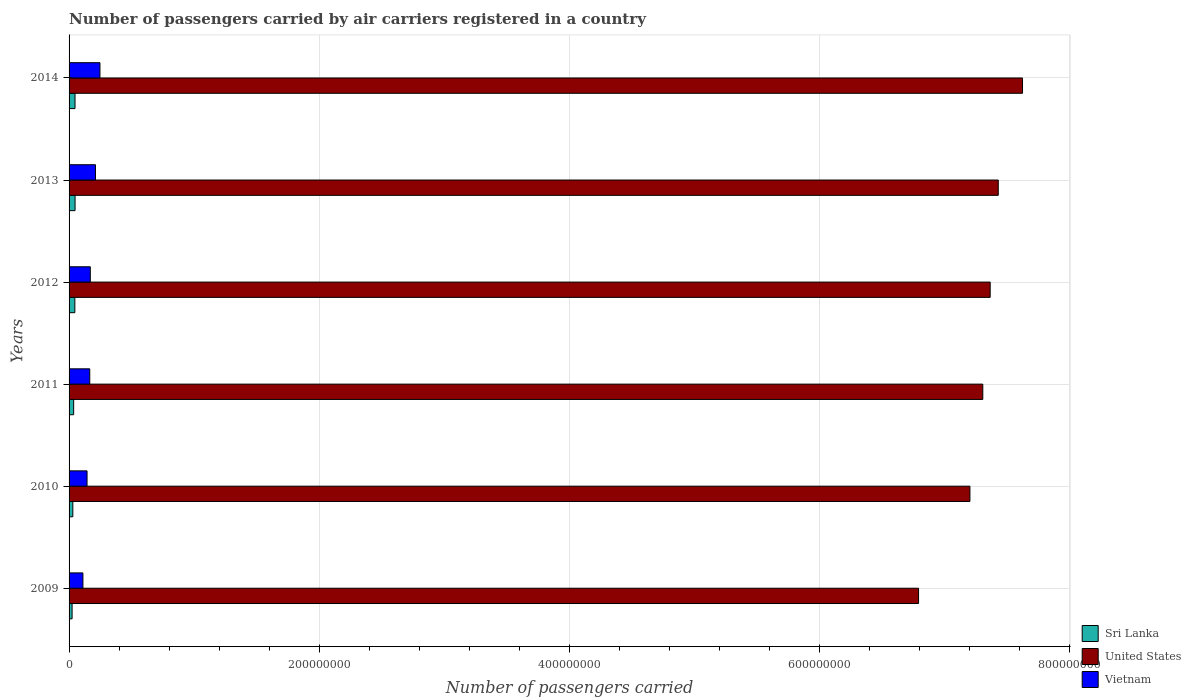Are the number of bars per tick equal to the number of legend labels?
Your answer should be very brief. Yes. How many bars are there on the 3rd tick from the top?
Your response must be concise. 3. What is the number of passengers carried by air carriers in Sri Lanka in 2011?
Provide a short and direct response. 3.67e+06. Across all years, what is the maximum number of passengers carried by air carriers in Vietnam?
Give a very brief answer. 2.47e+07. Across all years, what is the minimum number of passengers carried by air carriers in Vietnam?
Provide a short and direct response. 1.11e+07. In which year was the number of passengers carried by air carriers in Vietnam maximum?
Your response must be concise. 2014. What is the total number of passengers carried by air carriers in Vietnam in the graph?
Your response must be concise. 1.05e+08. What is the difference between the number of passengers carried by air carriers in Vietnam in 2010 and that in 2014?
Offer a terse response. -1.03e+07. What is the difference between the number of passengers carried by air carriers in Vietnam in 2010 and the number of passengers carried by air carriers in United States in 2011?
Make the answer very short. -7.16e+08. What is the average number of passengers carried by air carriers in United States per year?
Provide a succinct answer. 7.29e+08. In the year 2012, what is the difference between the number of passengers carried by air carriers in United States and number of passengers carried by air carriers in Sri Lanka?
Your answer should be compact. 7.32e+08. In how many years, is the number of passengers carried by air carriers in United States greater than 760000000 ?
Give a very brief answer. 1. What is the ratio of the number of passengers carried by air carriers in United States in 2010 to that in 2011?
Your response must be concise. 0.99. What is the difference between the highest and the second highest number of passengers carried by air carriers in United States?
Your answer should be compact. 1.94e+07. What is the difference between the highest and the lowest number of passengers carried by air carriers in United States?
Keep it short and to the point. 8.31e+07. What does the 3rd bar from the top in 2009 represents?
Make the answer very short. Sri Lanka. What does the 3rd bar from the bottom in 2013 represents?
Ensure brevity in your answer.  Vietnam. How many years are there in the graph?
Your answer should be compact. 6. What is the difference between two consecutive major ticks on the X-axis?
Offer a terse response. 2.00e+08. Are the values on the major ticks of X-axis written in scientific E-notation?
Offer a terse response. No. Does the graph contain any zero values?
Provide a succinct answer. No. Does the graph contain grids?
Provide a succinct answer. Yes. How many legend labels are there?
Provide a short and direct response. 3. What is the title of the graph?
Provide a short and direct response. Number of passengers carried by air carriers registered in a country. What is the label or title of the X-axis?
Your response must be concise. Number of passengers carried. What is the label or title of the Y-axis?
Ensure brevity in your answer.  Years. What is the Number of passengers carried of Sri Lanka in 2009?
Your answer should be very brief. 2.42e+06. What is the Number of passengers carried of United States in 2009?
Ensure brevity in your answer.  6.79e+08. What is the Number of passengers carried in Vietnam in 2009?
Give a very brief answer. 1.11e+07. What is the Number of passengers carried of Sri Lanka in 2010?
Your answer should be very brief. 3.01e+06. What is the Number of passengers carried in United States in 2010?
Offer a very short reply. 7.20e+08. What is the Number of passengers carried of Vietnam in 2010?
Ensure brevity in your answer.  1.44e+07. What is the Number of passengers carried of Sri Lanka in 2011?
Provide a short and direct response. 3.67e+06. What is the Number of passengers carried of United States in 2011?
Make the answer very short. 7.31e+08. What is the Number of passengers carried of Vietnam in 2011?
Ensure brevity in your answer.  1.65e+07. What is the Number of passengers carried in Sri Lanka in 2012?
Make the answer very short. 4.62e+06. What is the Number of passengers carried in United States in 2012?
Provide a short and direct response. 7.37e+08. What is the Number of passengers carried in Vietnam in 2012?
Your answer should be compact. 1.70e+07. What is the Number of passengers carried in Sri Lanka in 2013?
Your answer should be very brief. 4.79e+06. What is the Number of passengers carried of United States in 2013?
Your answer should be very brief. 7.43e+08. What is the Number of passengers carried of Vietnam in 2013?
Your answer should be compact. 2.11e+07. What is the Number of passengers carried of Sri Lanka in 2014?
Offer a very short reply. 4.76e+06. What is the Number of passengers carried of United States in 2014?
Your response must be concise. 7.63e+08. What is the Number of passengers carried of Vietnam in 2014?
Give a very brief answer. 2.47e+07. Across all years, what is the maximum Number of passengers carried in Sri Lanka?
Ensure brevity in your answer.  4.79e+06. Across all years, what is the maximum Number of passengers carried in United States?
Offer a very short reply. 7.63e+08. Across all years, what is the maximum Number of passengers carried of Vietnam?
Give a very brief answer. 2.47e+07. Across all years, what is the minimum Number of passengers carried of Sri Lanka?
Keep it short and to the point. 2.42e+06. Across all years, what is the minimum Number of passengers carried of United States?
Provide a succinct answer. 6.79e+08. Across all years, what is the minimum Number of passengers carried in Vietnam?
Your answer should be very brief. 1.11e+07. What is the total Number of passengers carried in Sri Lanka in the graph?
Keep it short and to the point. 2.33e+07. What is the total Number of passengers carried of United States in the graph?
Keep it short and to the point. 4.37e+09. What is the total Number of passengers carried of Vietnam in the graph?
Offer a terse response. 1.05e+08. What is the difference between the Number of passengers carried in Sri Lanka in 2009 and that in 2010?
Your answer should be compact. -5.91e+05. What is the difference between the Number of passengers carried of United States in 2009 and that in 2010?
Make the answer very short. -4.11e+07. What is the difference between the Number of passengers carried of Vietnam in 2009 and that in 2010?
Provide a short and direct response. -3.30e+06. What is the difference between the Number of passengers carried of Sri Lanka in 2009 and that in 2011?
Your answer should be very brief. -1.25e+06. What is the difference between the Number of passengers carried of United States in 2009 and that in 2011?
Offer a very short reply. -5.14e+07. What is the difference between the Number of passengers carried of Vietnam in 2009 and that in 2011?
Your response must be concise. -5.47e+06. What is the difference between the Number of passengers carried in Sri Lanka in 2009 and that in 2012?
Make the answer very short. -2.20e+06. What is the difference between the Number of passengers carried of United States in 2009 and that in 2012?
Your answer should be compact. -5.73e+07. What is the difference between the Number of passengers carried of Vietnam in 2009 and that in 2012?
Your answer should be very brief. -5.90e+06. What is the difference between the Number of passengers carried of Sri Lanka in 2009 and that in 2013?
Give a very brief answer. -2.38e+06. What is the difference between the Number of passengers carried of United States in 2009 and that in 2013?
Your answer should be compact. -6.37e+07. What is the difference between the Number of passengers carried of Vietnam in 2009 and that in 2013?
Your answer should be very brief. -1.00e+07. What is the difference between the Number of passengers carried of Sri Lanka in 2009 and that in 2014?
Your answer should be very brief. -2.34e+06. What is the difference between the Number of passengers carried in United States in 2009 and that in 2014?
Give a very brief answer. -8.31e+07. What is the difference between the Number of passengers carried of Vietnam in 2009 and that in 2014?
Ensure brevity in your answer.  -1.36e+07. What is the difference between the Number of passengers carried in Sri Lanka in 2010 and that in 2011?
Offer a terse response. -6.57e+05. What is the difference between the Number of passengers carried in United States in 2010 and that in 2011?
Provide a succinct answer. -1.03e+07. What is the difference between the Number of passengers carried of Vietnam in 2010 and that in 2011?
Provide a short and direct response. -2.17e+06. What is the difference between the Number of passengers carried in Sri Lanka in 2010 and that in 2012?
Your response must be concise. -1.61e+06. What is the difference between the Number of passengers carried in United States in 2010 and that in 2012?
Provide a succinct answer. -1.62e+07. What is the difference between the Number of passengers carried of Vietnam in 2010 and that in 2012?
Give a very brief answer. -2.60e+06. What is the difference between the Number of passengers carried in Sri Lanka in 2010 and that in 2013?
Your response must be concise. -1.79e+06. What is the difference between the Number of passengers carried of United States in 2010 and that in 2013?
Provide a short and direct response. -2.27e+07. What is the difference between the Number of passengers carried of Vietnam in 2010 and that in 2013?
Your answer should be compact. -6.74e+06. What is the difference between the Number of passengers carried in Sri Lanka in 2010 and that in 2014?
Ensure brevity in your answer.  -1.75e+06. What is the difference between the Number of passengers carried of United States in 2010 and that in 2014?
Ensure brevity in your answer.  -4.21e+07. What is the difference between the Number of passengers carried of Vietnam in 2010 and that in 2014?
Your answer should be compact. -1.03e+07. What is the difference between the Number of passengers carried of Sri Lanka in 2011 and that in 2012?
Make the answer very short. -9.51e+05. What is the difference between the Number of passengers carried in United States in 2011 and that in 2012?
Your response must be concise. -5.90e+06. What is the difference between the Number of passengers carried in Vietnam in 2011 and that in 2012?
Offer a very short reply. -4.32e+05. What is the difference between the Number of passengers carried of Sri Lanka in 2011 and that in 2013?
Offer a very short reply. -1.13e+06. What is the difference between the Number of passengers carried of United States in 2011 and that in 2013?
Keep it short and to the point. -1.24e+07. What is the difference between the Number of passengers carried in Vietnam in 2011 and that in 2013?
Your answer should be very brief. -4.58e+06. What is the difference between the Number of passengers carried of Sri Lanka in 2011 and that in 2014?
Ensure brevity in your answer.  -1.09e+06. What is the difference between the Number of passengers carried of United States in 2011 and that in 2014?
Offer a terse response. -3.18e+07. What is the difference between the Number of passengers carried of Vietnam in 2011 and that in 2014?
Provide a succinct answer. -8.16e+06. What is the difference between the Number of passengers carried of Sri Lanka in 2012 and that in 2013?
Your response must be concise. -1.77e+05. What is the difference between the Number of passengers carried in United States in 2012 and that in 2013?
Keep it short and to the point. -6.47e+06. What is the difference between the Number of passengers carried in Vietnam in 2012 and that in 2013?
Ensure brevity in your answer.  -4.15e+06. What is the difference between the Number of passengers carried in Sri Lanka in 2012 and that in 2014?
Your response must be concise. -1.40e+05. What is the difference between the Number of passengers carried of United States in 2012 and that in 2014?
Offer a terse response. -2.59e+07. What is the difference between the Number of passengers carried of Vietnam in 2012 and that in 2014?
Make the answer very short. -7.73e+06. What is the difference between the Number of passengers carried in Sri Lanka in 2013 and that in 2014?
Your response must be concise. 3.75e+04. What is the difference between the Number of passengers carried in United States in 2013 and that in 2014?
Offer a very short reply. -1.94e+07. What is the difference between the Number of passengers carried of Vietnam in 2013 and that in 2014?
Give a very brief answer. -3.58e+06. What is the difference between the Number of passengers carried in Sri Lanka in 2009 and the Number of passengers carried in United States in 2010?
Make the answer very short. -7.18e+08. What is the difference between the Number of passengers carried in Sri Lanka in 2009 and the Number of passengers carried in Vietnam in 2010?
Provide a short and direct response. -1.20e+07. What is the difference between the Number of passengers carried in United States in 2009 and the Number of passengers carried in Vietnam in 2010?
Provide a succinct answer. 6.65e+08. What is the difference between the Number of passengers carried in Sri Lanka in 2009 and the Number of passengers carried in United States in 2011?
Offer a very short reply. -7.28e+08. What is the difference between the Number of passengers carried in Sri Lanka in 2009 and the Number of passengers carried in Vietnam in 2011?
Offer a very short reply. -1.41e+07. What is the difference between the Number of passengers carried of United States in 2009 and the Number of passengers carried of Vietnam in 2011?
Your answer should be compact. 6.63e+08. What is the difference between the Number of passengers carried of Sri Lanka in 2009 and the Number of passengers carried of United States in 2012?
Your answer should be very brief. -7.34e+08. What is the difference between the Number of passengers carried in Sri Lanka in 2009 and the Number of passengers carried in Vietnam in 2012?
Offer a very short reply. -1.46e+07. What is the difference between the Number of passengers carried in United States in 2009 and the Number of passengers carried in Vietnam in 2012?
Your answer should be very brief. 6.62e+08. What is the difference between the Number of passengers carried of Sri Lanka in 2009 and the Number of passengers carried of United States in 2013?
Your response must be concise. -7.41e+08. What is the difference between the Number of passengers carried of Sri Lanka in 2009 and the Number of passengers carried of Vietnam in 2013?
Offer a terse response. -1.87e+07. What is the difference between the Number of passengers carried in United States in 2009 and the Number of passengers carried in Vietnam in 2013?
Your answer should be very brief. 6.58e+08. What is the difference between the Number of passengers carried of Sri Lanka in 2009 and the Number of passengers carried of United States in 2014?
Your answer should be very brief. -7.60e+08. What is the difference between the Number of passengers carried in Sri Lanka in 2009 and the Number of passengers carried in Vietnam in 2014?
Your response must be concise. -2.23e+07. What is the difference between the Number of passengers carried of United States in 2009 and the Number of passengers carried of Vietnam in 2014?
Offer a terse response. 6.55e+08. What is the difference between the Number of passengers carried of Sri Lanka in 2010 and the Number of passengers carried of United States in 2011?
Your response must be concise. -7.28e+08. What is the difference between the Number of passengers carried in Sri Lanka in 2010 and the Number of passengers carried in Vietnam in 2011?
Keep it short and to the point. -1.35e+07. What is the difference between the Number of passengers carried in United States in 2010 and the Number of passengers carried in Vietnam in 2011?
Provide a succinct answer. 7.04e+08. What is the difference between the Number of passengers carried in Sri Lanka in 2010 and the Number of passengers carried in United States in 2012?
Provide a short and direct response. -7.34e+08. What is the difference between the Number of passengers carried of Sri Lanka in 2010 and the Number of passengers carried of Vietnam in 2012?
Keep it short and to the point. -1.40e+07. What is the difference between the Number of passengers carried of United States in 2010 and the Number of passengers carried of Vietnam in 2012?
Make the answer very short. 7.04e+08. What is the difference between the Number of passengers carried in Sri Lanka in 2010 and the Number of passengers carried in United States in 2013?
Provide a short and direct response. -7.40e+08. What is the difference between the Number of passengers carried in Sri Lanka in 2010 and the Number of passengers carried in Vietnam in 2013?
Provide a short and direct response. -1.81e+07. What is the difference between the Number of passengers carried in United States in 2010 and the Number of passengers carried in Vietnam in 2013?
Your response must be concise. 6.99e+08. What is the difference between the Number of passengers carried of Sri Lanka in 2010 and the Number of passengers carried of United States in 2014?
Your response must be concise. -7.60e+08. What is the difference between the Number of passengers carried in Sri Lanka in 2010 and the Number of passengers carried in Vietnam in 2014?
Your answer should be very brief. -2.17e+07. What is the difference between the Number of passengers carried of United States in 2010 and the Number of passengers carried of Vietnam in 2014?
Offer a terse response. 6.96e+08. What is the difference between the Number of passengers carried of Sri Lanka in 2011 and the Number of passengers carried of United States in 2012?
Your answer should be compact. -7.33e+08. What is the difference between the Number of passengers carried of Sri Lanka in 2011 and the Number of passengers carried of Vietnam in 2012?
Give a very brief answer. -1.33e+07. What is the difference between the Number of passengers carried in United States in 2011 and the Number of passengers carried in Vietnam in 2012?
Offer a terse response. 7.14e+08. What is the difference between the Number of passengers carried in Sri Lanka in 2011 and the Number of passengers carried in United States in 2013?
Offer a terse response. -7.40e+08. What is the difference between the Number of passengers carried of Sri Lanka in 2011 and the Number of passengers carried of Vietnam in 2013?
Ensure brevity in your answer.  -1.75e+07. What is the difference between the Number of passengers carried in United States in 2011 and the Number of passengers carried in Vietnam in 2013?
Offer a very short reply. 7.10e+08. What is the difference between the Number of passengers carried of Sri Lanka in 2011 and the Number of passengers carried of United States in 2014?
Provide a succinct answer. -7.59e+08. What is the difference between the Number of passengers carried in Sri Lanka in 2011 and the Number of passengers carried in Vietnam in 2014?
Ensure brevity in your answer.  -2.10e+07. What is the difference between the Number of passengers carried in United States in 2011 and the Number of passengers carried in Vietnam in 2014?
Ensure brevity in your answer.  7.06e+08. What is the difference between the Number of passengers carried of Sri Lanka in 2012 and the Number of passengers carried of United States in 2013?
Give a very brief answer. -7.39e+08. What is the difference between the Number of passengers carried in Sri Lanka in 2012 and the Number of passengers carried in Vietnam in 2013?
Keep it short and to the point. -1.65e+07. What is the difference between the Number of passengers carried of United States in 2012 and the Number of passengers carried of Vietnam in 2013?
Give a very brief answer. 7.16e+08. What is the difference between the Number of passengers carried of Sri Lanka in 2012 and the Number of passengers carried of United States in 2014?
Offer a very short reply. -7.58e+08. What is the difference between the Number of passengers carried in Sri Lanka in 2012 and the Number of passengers carried in Vietnam in 2014?
Make the answer very short. -2.01e+07. What is the difference between the Number of passengers carried of United States in 2012 and the Number of passengers carried of Vietnam in 2014?
Give a very brief answer. 7.12e+08. What is the difference between the Number of passengers carried of Sri Lanka in 2013 and the Number of passengers carried of United States in 2014?
Keep it short and to the point. -7.58e+08. What is the difference between the Number of passengers carried in Sri Lanka in 2013 and the Number of passengers carried in Vietnam in 2014?
Provide a succinct answer. -1.99e+07. What is the difference between the Number of passengers carried of United States in 2013 and the Number of passengers carried of Vietnam in 2014?
Your answer should be compact. 7.18e+08. What is the average Number of passengers carried in Sri Lanka per year?
Provide a succinct answer. 3.88e+06. What is the average Number of passengers carried in United States per year?
Ensure brevity in your answer.  7.29e+08. What is the average Number of passengers carried of Vietnam per year?
Offer a very short reply. 1.75e+07. In the year 2009, what is the difference between the Number of passengers carried of Sri Lanka and Number of passengers carried of United States?
Your response must be concise. -6.77e+08. In the year 2009, what is the difference between the Number of passengers carried of Sri Lanka and Number of passengers carried of Vietnam?
Offer a very short reply. -8.66e+06. In the year 2009, what is the difference between the Number of passengers carried in United States and Number of passengers carried in Vietnam?
Give a very brief answer. 6.68e+08. In the year 2010, what is the difference between the Number of passengers carried in Sri Lanka and Number of passengers carried in United States?
Your response must be concise. -7.17e+08. In the year 2010, what is the difference between the Number of passengers carried in Sri Lanka and Number of passengers carried in Vietnam?
Provide a succinct answer. -1.14e+07. In the year 2010, what is the difference between the Number of passengers carried of United States and Number of passengers carried of Vietnam?
Offer a very short reply. 7.06e+08. In the year 2011, what is the difference between the Number of passengers carried in Sri Lanka and Number of passengers carried in United States?
Offer a very short reply. -7.27e+08. In the year 2011, what is the difference between the Number of passengers carried of Sri Lanka and Number of passengers carried of Vietnam?
Your response must be concise. -1.29e+07. In the year 2011, what is the difference between the Number of passengers carried of United States and Number of passengers carried of Vietnam?
Your answer should be very brief. 7.14e+08. In the year 2012, what is the difference between the Number of passengers carried in Sri Lanka and Number of passengers carried in United States?
Your response must be concise. -7.32e+08. In the year 2012, what is the difference between the Number of passengers carried of Sri Lanka and Number of passengers carried of Vietnam?
Make the answer very short. -1.24e+07. In the year 2012, what is the difference between the Number of passengers carried in United States and Number of passengers carried in Vietnam?
Your response must be concise. 7.20e+08. In the year 2013, what is the difference between the Number of passengers carried of Sri Lanka and Number of passengers carried of United States?
Provide a short and direct response. -7.38e+08. In the year 2013, what is the difference between the Number of passengers carried of Sri Lanka and Number of passengers carried of Vietnam?
Offer a very short reply. -1.63e+07. In the year 2013, what is the difference between the Number of passengers carried of United States and Number of passengers carried of Vietnam?
Your answer should be very brief. 7.22e+08. In the year 2014, what is the difference between the Number of passengers carried in Sri Lanka and Number of passengers carried in United States?
Your response must be concise. -7.58e+08. In the year 2014, what is the difference between the Number of passengers carried of Sri Lanka and Number of passengers carried of Vietnam?
Your answer should be compact. -1.99e+07. In the year 2014, what is the difference between the Number of passengers carried in United States and Number of passengers carried in Vietnam?
Your answer should be very brief. 7.38e+08. What is the ratio of the Number of passengers carried in Sri Lanka in 2009 to that in 2010?
Ensure brevity in your answer.  0.8. What is the ratio of the Number of passengers carried of United States in 2009 to that in 2010?
Your answer should be very brief. 0.94. What is the ratio of the Number of passengers carried of Vietnam in 2009 to that in 2010?
Give a very brief answer. 0.77. What is the ratio of the Number of passengers carried of Sri Lanka in 2009 to that in 2011?
Give a very brief answer. 0.66. What is the ratio of the Number of passengers carried in United States in 2009 to that in 2011?
Make the answer very short. 0.93. What is the ratio of the Number of passengers carried of Vietnam in 2009 to that in 2011?
Keep it short and to the point. 0.67. What is the ratio of the Number of passengers carried of Sri Lanka in 2009 to that in 2012?
Your answer should be compact. 0.52. What is the ratio of the Number of passengers carried in United States in 2009 to that in 2012?
Your response must be concise. 0.92. What is the ratio of the Number of passengers carried in Vietnam in 2009 to that in 2012?
Your answer should be very brief. 0.65. What is the ratio of the Number of passengers carried of Sri Lanka in 2009 to that in 2013?
Make the answer very short. 0.5. What is the ratio of the Number of passengers carried in United States in 2009 to that in 2013?
Your answer should be very brief. 0.91. What is the ratio of the Number of passengers carried of Vietnam in 2009 to that in 2013?
Give a very brief answer. 0.52. What is the ratio of the Number of passengers carried of Sri Lanka in 2009 to that in 2014?
Keep it short and to the point. 0.51. What is the ratio of the Number of passengers carried in United States in 2009 to that in 2014?
Your answer should be compact. 0.89. What is the ratio of the Number of passengers carried in Vietnam in 2009 to that in 2014?
Provide a short and direct response. 0.45. What is the ratio of the Number of passengers carried of Sri Lanka in 2010 to that in 2011?
Your response must be concise. 0.82. What is the ratio of the Number of passengers carried in United States in 2010 to that in 2011?
Your answer should be compact. 0.99. What is the ratio of the Number of passengers carried of Vietnam in 2010 to that in 2011?
Your response must be concise. 0.87. What is the ratio of the Number of passengers carried in Sri Lanka in 2010 to that in 2012?
Provide a succinct answer. 0.65. What is the ratio of the Number of passengers carried of United States in 2010 to that in 2012?
Your answer should be very brief. 0.98. What is the ratio of the Number of passengers carried of Vietnam in 2010 to that in 2012?
Ensure brevity in your answer.  0.85. What is the ratio of the Number of passengers carried of Sri Lanka in 2010 to that in 2013?
Your answer should be very brief. 0.63. What is the ratio of the Number of passengers carried in United States in 2010 to that in 2013?
Your answer should be very brief. 0.97. What is the ratio of the Number of passengers carried in Vietnam in 2010 to that in 2013?
Give a very brief answer. 0.68. What is the ratio of the Number of passengers carried in Sri Lanka in 2010 to that in 2014?
Ensure brevity in your answer.  0.63. What is the ratio of the Number of passengers carried of United States in 2010 to that in 2014?
Ensure brevity in your answer.  0.94. What is the ratio of the Number of passengers carried in Vietnam in 2010 to that in 2014?
Give a very brief answer. 0.58. What is the ratio of the Number of passengers carried in Sri Lanka in 2011 to that in 2012?
Your answer should be compact. 0.79. What is the ratio of the Number of passengers carried of Vietnam in 2011 to that in 2012?
Provide a short and direct response. 0.97. What is the ratio of the Number of passengers carried of Sri Lanka in 2011 to that in 2013?
Offer a very short reply. 0.76. What is the ratio of the Number of passengers carried in United States in 2011 to that in 2013?
Give a very brief answer. 0.98. What is the ratio of the Number of passengers carried in Vietnam in 2011 to that in 2013?
Provide a short and direct response. 0.78. What is the ratio of the Number of passengers carried in Sri Lanka in 2011 to that in 2014?
Provide a succinct answer. 0.77. What is the ratio of the Number of passengers carried of United States in 2011 to that in 2014?
Offer a terse response. 0.96. What is the ratio of the Number of passengers carried in Vietnam in 2011 to that in 2014?
Your answer should be compact. 0.67. What is the ratio of the Number of passengers carried of United States in 2012 to that in 2013?
Keep it short and to the point. 0.99. What is the ratio of the Number of passengers carried in Vietnam in 2012 to that in 2013?
Your answer should be compact. 0.8. What is the ratio of the Number of passengers carried in Sri Lanka in 2012 to that in 2014?
Give a very brief answer. 0.97. What is the ratio of the Number of passengers carried of United States in 2012 to that in 2014?
Provide a short and direct response. 0.97. What is the ratio of the Number of passengers carried in Vietnam in 2012 to that in 2014?
Provide a short and direct response. 0.69. What is the ratio of the Number of passengers carried in Sri Lanka in 2013 to that in 2014?
Keep it short and to the point. 1.01. What is the ratio of the Number of passengers carried of United States in 2013 to that in 2014?
Make the answer very short. 0.97. What is the ratio of the Number of passengers carried of Vietnam in 2013 to that in 2014?
Make the answer very short. 0.85. What is the difference between the highest and the second highest Number of passengers carried in Sri Lanka?
Your response must be concise. 3.75e+04. What is the difference between the highest and the second highest Number of passengers carried of United States?
Your answer should be compact. 1.94e+07. What is the difference between the highest and the second highest Number of passengers carried of Vietnam?
Offer a very short reply. 3.58e+06. What is the difference between the highest and the lowest Number of passengers carried in Sri Lanka?
Offer a very short reply. 2.38e+06. What is the difference between the highest and the lowest Number of passengers carried in United States?
Ensure brevity in your answer.  8.31e+07. What is the difference between the highest and the lowest Number of passengers carried of Vietnam?
Keep it short and to the point. 1.36e+07. 